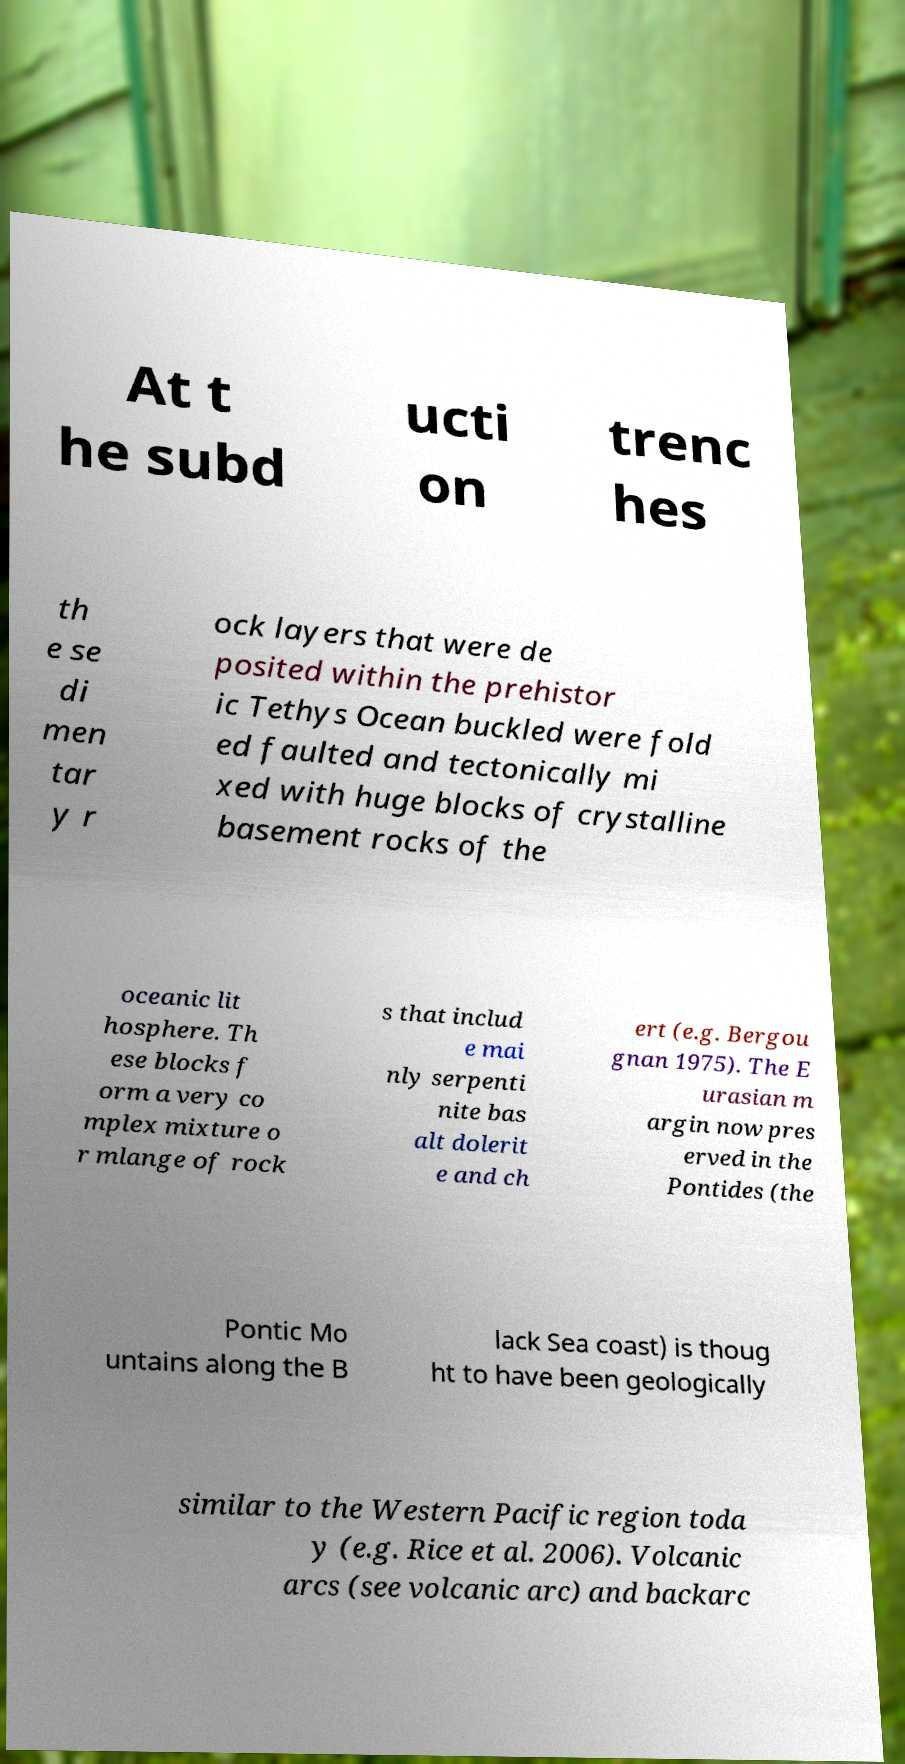I need the written content from this picture converted into text. Can you do that? At t he subd ucti on trenc hes th e se di men tar y r ock layers that were de posited within the prehistor ic Tethys Ocean buckled were fold ed faulted and tectonically mi xed with huge blocks of crystalline basement rocks of the oceanic lit hosphere. Th ese blocks f orm a very co mplex mixture o r mlange of rock s that includ e mai nly serpenti nite bas alt dolerit e and ch ert (e.g. Bergou gnan 1975). The E urasian m argin now pres erved in the Pontides (the Pontic Mo untains along the B lack Sea coast) is thoug ht to have been geologically similar to the Western Pacific region toda y (e.g. Rice et al. 2006). Volcanic arcs (see volcanic arc) and backarc 